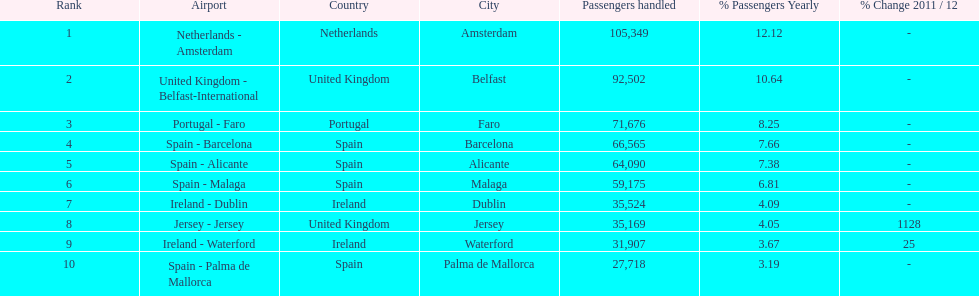Which airport has the least amount of passengers going through london southend airport? Spain - Palma de Mallorca. 